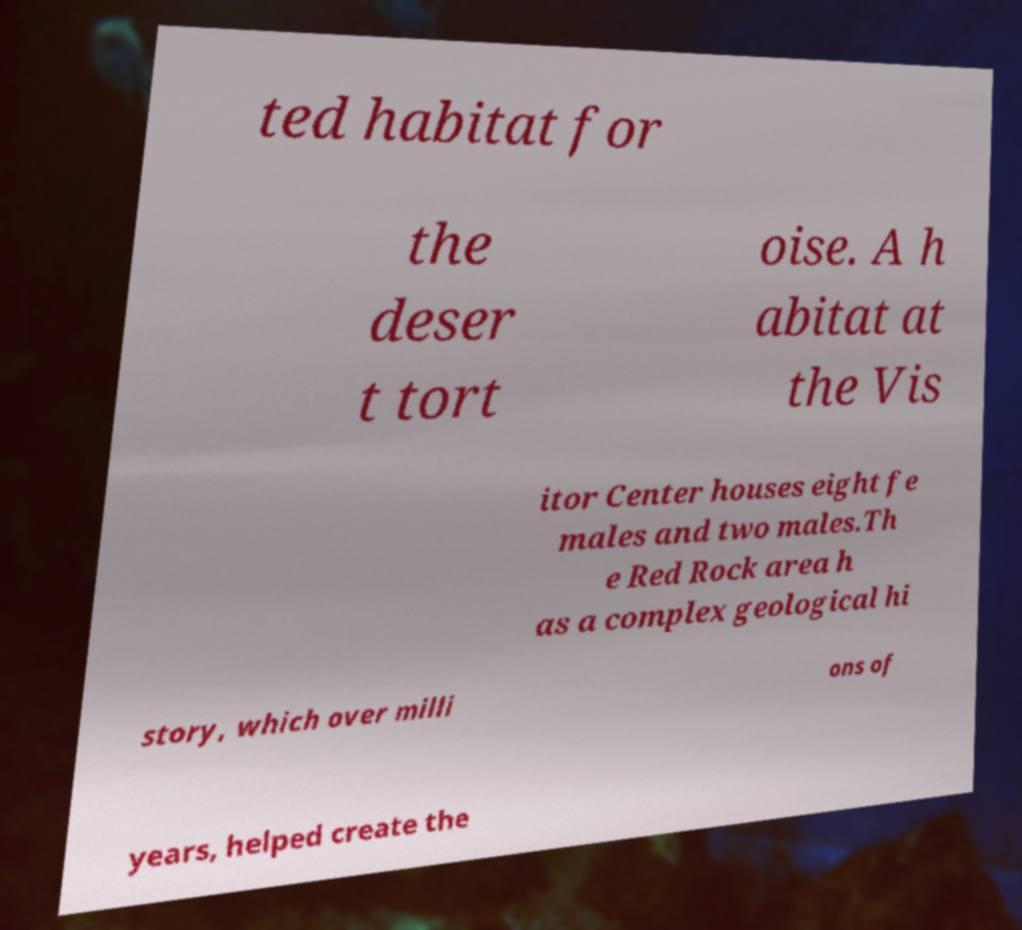There's text embedded in this image that I need extracted. Can you transcribe it verbatim? ted habitat for the deser t tort oise. A h abitat at the Vis itor Center houses eight fe males and two males.Th e Red Rock area h as a complex geological hi story, which over milli ons of years, helped create the 